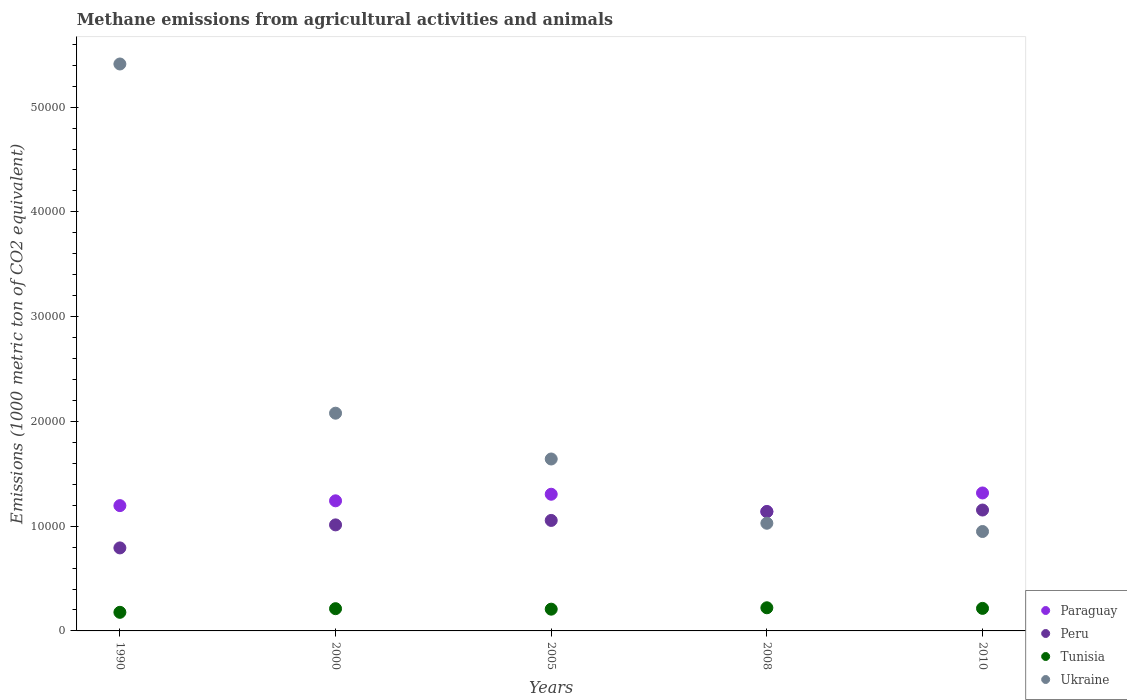What is the amount of methane emitted in Peru in 2010?
Give a very brief answer. 1.15e+04. Across all years, what is the maximum amount of methane emitted in Ukraine?
Offer a very short reply. 5.41e+04. Across all years, what is the minimum amount of methane emitted in Ukraine?
Provide a short and direct response. 9489.8. In which year was the amount of methane emitted in Ukraine minimum?
Ensure brevity in your answer.  2010. What is the total amount of methane emitted in Tunisia in the graph?
Your answer should be very brief. 1.03e+04. What is the difference between the amount of methane emitted in Paraguay in 2005 and that in 2008?
Provide a short and direct response. 1659.4. What is the difference between the amount of methane emitted in Peru in 2005 and the amount of methane emitted in Tunisia in 2010?
Offer a very short reply. 8395.2. What is the average amount of methane emitted in Peru per year?
Offer a very short reply. 1.03e+04. In the year 2005, what is the difference between the amount of methane emitted in Ukraine and amount of methane emitted in Peru?
Offer a very short reply. 5864.3. What is the ratio of the amount of methane emitted in Tunisia in 1990 to that in 2008?
Offer a terse response. 0.8. Is the difference between the amount of methane emitted in Ukraine in 2008 and 2010 greater than the difference between the amount of methane emitted in Peru in 2008 and 2010?
Provide a succinct answer. Yes. What is the difference between the highest and the second highest amount of methane emitted in Tunisia?
Provide a succinct answer. 57.9. What is the difference between the highest and the lowest amount of methane emitted in Paraguay?
Your answer should be compact. 1782.6. In how many years, is the amount of methane emitted in Ukraine greater than the average amount of methane emitted in Ukraine taken over all years?
Make the answer very short. 1. Is the sum of the amount of methane emitted in Tunisia in 2005 and 2008 greater than the maximum amount of methane emitted in Ukraine across all years?
Give a very brief answer. No. Is it the case that in every year, the sum of the amount of methane emitted in Ukraine and amount of methane emitted in Paraguay  is greater than the amount of methane emitted in Peru?
Give a very brief answer. Yes. Does the amount of methane emitted in Peru monotonically increase over the years?
Your answer should be compact. Yes. How many years are there in the graph?
Provide a short and direct response. 5. Does the graph contain any zero values?
Make the answer very short. No. Where does the legend appear in the graph?
Provide a short and direct response. Bottom right. How are the legend labels stacked?
Give a very brief answer. Vertical. What is the title of the graph?
Offer a terse response. Methane emissions from agricultural activities and animals. Does "United States" appear as one of the legend labels in the graph?
Your answer should be very brief. No. What is the label or title of the X-axis?
Provide a short and direct response. Years. What is the label or title of the Y-axis?
Your response must be concise. Emissions (1000 metric ton of CO2 equivalent). What is the Emissions (1000 metric ton of CO2 equivalent) in Paraguay in 1990?
Ensure brevity in your answer.  1.20e+04. What is the Emissions (1000 metric ton of CO2 equivalent) of Peru in 1990?
Provide a succinct answer. 7923.7. What is the Emissions (1000 metric ton of CO2 equivalent) in Tunisia in 1990?
Offer a terse response. 1775.7. What is the Emissions (1000 metric ton of CO2 equivalent) of Ukraine in 1990?
Provide a short and direct response. 5.41e+04. What is the Emissions (1000 metric ton of CO2 equivalent) of Paraguay in 2000?
Make the answer very short. 1.24e+04. What is the Emissions (1000 metric ton of CO2 equivalent) of Peru in 2000?
Your response must be concise. 1.01e+04. What is the Emissions (1000 metric ton of CO2 equivalent) of Tunisia in 2000?
Your answer should be compact. 2123.8. What is the Emissions (1000 metric ton of CO2 equivalent) of Ukraine in 2000?
Keep it short and to the point. 2.08e+04. What is the Emissions (1000 metric ton of CO2 equivalent) in Paraguay in 2005?
Offer a terse response. 1.30e+04. What is the Emissions (1000 metric ton of CO2 equivalent) in Peru in 2005?
Ensure brevity in your answer.  1.05e+04. What is the Emissions (1000 metric ton of CO2 equivalent) in Tunisia in 2005?
Your answer should be very brief. 2076.8. What is the Emissions (1000 metric ton of CO2 equivalent) of Ukraine in 2005?
Provide a short and direct response. 1.64e+04. What is the Emissions (1000 metric ton of CO2 equivalent) of Paraguay in 2008?
Your answer should be very brief. 1.14e+04. What is the Emissions (1000 metric ton of CO2 equivalent) in Peru in 2008?
Your answer should be compact. 1.14e+04. What is the Emissions (1000 metric ton of CO2 equivalent) of Tunisia in 2008?
Provide a short and direct response. 2209.8. What is the Emissions (1000 metric ton of CO2 equivalent) of Ukraine in 2008?
Offer a very short reply. 1.03e+04. What is the Emissions (1000 metric ton of CO2 equivalent) in Paraguay in 2010?
Your answer should be compact. 1.32e+04. What is the Emissions (1000 metric ton of CO2 equivalent) of Peru in 2010?
Your response must be concise. 1.15e+04. What is the Emissions (1000 metric ton of CO2 equivalent) in Tunisia in 2010?
Ensure brevity in your answer.  2151.9. What is the Emissions (1000 metric ton of CO2 equivalent) of Ukraine in 2010?
Provide a short and direct response. 9489.8. Across all years, what is the maximum Emissions (1000 metric ton of CO2 equivalent) in Paraguay?
Keep it short and to the point. 1.32e+04. Across all years, what is the maximum Emissions (1000 metric ton of CO2 equivalent) of Peru?
Offer a terse response. 1.15e+04. Across all years, what is the maximum Emissions (1000 metric ton of CO2 equivalent) in Tunisia?
Provide a short and direct response. 2209.8. Across all years, what is the maximum Emissions (1000 metric ton of CO2 equivalent) of Ukraine?
Keep it short and to the point. 5.41e+04. Across all years, what is the minimum Emissions (1000 metric ton of CO2 equivalent) of Paraguay?
Offer a very short reply. 1.14e+04. Across all years, what is the minimum Emissions (1000 metric ton of CO2 equivalent) in Peru?
Offer a very short reply. 7923.7. Across all years, what is the minimum Emissions (1000 metric ton of CO2 equivalent) in Tunisia?
Keep it short and to the point. 1775.7. Across all years, what is the minimum Emissions (1000 metric ton of CO2 equivalent) in Ukraine?
Give a very brief answer. 9489.8. What is the total Emissions (1000 metric ton of CO2 equivalent) of Paraguay in the graph?
Your answer should be very brief. 6.20e+04. What is the total Emissions (1000 metric ton of CO2 equivalent) in Peru in the graph?
Your response must be concise. 5.15e+04. What is the total Emissions (1000 metric ton of CO2 equivalent) in Tunisia in the graph?
Keep it short and to the point. 1.03e+04. What is the total Emissions (1000 metric ton of CO2 equivalent) in Ukraine in the graph?
Provide a succinct answer. 1.11e+05. What is the difference between the Emissions (1000 metric ton of CO2 equivalent) in Paraguay in 1990 and that in 2000?
Give a very brief answer. -458.8. What is the difference between the Emissions (1000 metric ton of CO2 equivalent) in Peru in 1990 and that in 2000?
Keep it short and to the point. -2198.2. What is the difference between the Emissions (1000 metric ton of CO2 equivalent) of Tunisia in 1990 and that in 2000?
Your answer should be compact. -348.1. What is the difference between the Emissions (1000 metric ton of CO2 equivalent) in Ukraine in 1990 and that in 2000?
Your response must be concise. 3.33e+04. What is the difference between the Emissions (1000 metric ton of CO2 equivalent) in Paraguay in 1990 and that in 2005?
Provide a short and direct response. -1085.6. What is the difference between the Emissions (1000 metric ton of CO2 equivalent) in Peru in 1990 and that in 2005?
Keep it short and to the point. -2623.4. What is the difference between the Emissions (1000 metric ton of CO2 equivalent) of Tunisia in 1990 and that in 2005?
Keep it short and to the point. -301.1. What is the difference between the Emissions (1000 metric ton of CO2 equivalent) in Ukraine in 1990 and that in 2005?
Your answer should be very brief. 3.77e+04. What is the difference between the Emissions (1000 metric ton of CO2 equivalent) of Paraguay in 1990 and that in 2008?
Your answer should be very brief. 573.8. What is the difference between the Emissions (1000 metric ton of CO2 equivalent) of Peru in 1990 and that in 2008?
Provide a short and direct response. -3467.3. What is the difference between the Emissions (1000 metric ton of CO2 equivalent) of Tunisia in 1990 and that in 2008?
Make the answer very short. -434.1. What is the difference between the Emissions (1000 metric ton of CO2 equivalent) in Ukraine in 1990 and that in 2008?
Provide a succinct answer. 4.38e+04. What is the difference between the Emissions (1000 metric ton of CO2 equivalent) of Paraguay in 1990 and that in 2010?
Keep it short and to the point. -1208.8. What is the difference between the Emissions (1000 metric ton of CO2 equivalent) in Peru in 1990 and that in 2010?
Your answer should be very brief. -3615.7. What is the difference between the Emissions (1000 metric ton of CO2 equivalent) of Tunisia in 1990 and that in 2010?
Your answer should be very brief. -376.2. What is the difference between the Emissions (1000 metric ton of CO2 equivalent) of Ukraine in 1990 and that in 2010?
Provide a short and direct response. 4.46e+04. What is the difference between the Emissions (1000 metric ton of CO2 equivalent) in Paraguay in 2000 and that in 2005?
Provide a succinct answer. -626.8. What is the difference between the Emissions (1000 metric ton of CO2 equivalent) in Peru in 2000 and that in 2005?
Keep it short and to the point. -425.2. What is the difference between the Emissions (1000 metric ton of CO2 equivalent) of Tunisia in 2000 and that in 2005?
Offer a terse response. 47. What is the difference between the Emissions (1000 metric ton of CO2 equivalent) in Ukraine in 2000 and that in 2005?
Offer a very short reply. 4372.1. What is the difference between the Emissions (1000 metric ton of CO2 equivalent) of Paraguay in 2000 and that in 2008?
Ensure brevity in your answer.  1032.6. What is the difference between the Emissions (1000 metric ton of CO2 equivalent) in Peru in 2000 and that in 2008?
Offer a very short reply. -1269.1. What is the difference between the Emissions (1000 metric ton of CO2 equivalent) of Tunisia in 2000 and that in 2008?
Keep it short and to the point. -86. What is the difference between the Emissions (1000 metric ton of CO2 equivalent) of Ukraine in 2000 and that in 2008?
Provide a short and direct response. 1.05e+04. What is the difference between the Emissions (1000 metric ton of CO2 equivalent) of Paraguay in 2000 and that in 2010?
Offer a very short reply. -750. What is the difference between the Emissions (1000 metric ton of CO2 equivalent) of Peru in 2000 and that in 2010?
Make the answer very short. -1417.5. What is the difference between the Emissions (1000 metric ton of CO2 equivalent) of Tunisia in 2000 and that in 2010?
Ensure brevity in your answer.  -28.1. What is the difference between the Emissions (1000 metric ton of CO2 equivalent) in Ukraine in 2000 and that in 2010?
Give a very brief answer. 1.13e+04. What is the difference between the Emissions (1000 metric ton of CO2 equivalent) of Paraguay in 2005 and that in 2008?
Give a very brief answer. 1659.4. What is the difference between the Emissions (1000 metric ton of CO2 equivalent) in Peru in 2005 and that in 2008?
Offer a terse response. -843.9. What is the difference between the Emissions (1000 metric ton of CO2 equivalent) in Tunisia in 2005 and that in 2008?
Make the answer very short. -133. What is the difference between the Emissions (1000 metric ton of CO2 equivalent) in Ukraine in 2005 and that in 2008?
Ensure brevity in your answer.  6133.4. What is the difference between the Emissions (1000 metric ton of CO2 equivalent) in Paraguay in 2005 and that in 2010?
Keep it short and to the point. -123.2. What is the difference between the Emissions (1000 metric ton of CO2 equivalent) of Peru in 2005 and that in 2010?
Your answer should be very brief. -992.3. What is the difference between the Emissions (1000 metric ton of CO2 equivalent) of Tunisia in 2005 and that in 2010?
Keep it short and to the point. -75.1. What is the difference between the Emissions (1000 metric ton of CO2 equivalent) in Ukraine in 2005 and that in 2010?
Provide a succinct answer. 6921.6. What is the difference between the Emissions (1000 metric ton of CO2 equivalent) of Paraguay in 2008 and that in 2010?
Provide a short and direct response. -1782.6. What is the difference between the Emissions (1000 metric ton of CO2 equivalent) of Peru in 2008 and that in 2010?
Offer a very short reply. -148.4. What is the difference between the Emissions (1000 metric ton of CO2 equivalent) in Tunisia in 2008 and that in 2010?
Your answer should be very brief. 57.9. What is the difference between the Emissions (1000 metric ton of CO2 equivalent) in Ukraine in 2008 and that in 2010?
Give a very brief answer. 788.2. What is the difference between the Emissions (1000 metric ton of CO2 equivalent) of Paraguay in 1990 and the Emissions (1000 metric ton of CO2 equivalent) of Peru in 2000?
Provide a succinct answer. 1838.5. What is the difference between the Emissions (1000 metric ton of CO2 equivalent) of Paraguay in 1990 and the Emissions (1000 metric ton of CO2 equivalent) of Tunisia in 2000?
Make the answer very short. 9836.6. What is the difference between the Emissions (1000 metric ton of CO2 equivalent) of Paraguay in 1990 and the Emissions (1000 metric ton of CO2 equivalent) of Ukraine in 2000?
Your answer should be very brief. -8823.1. What is the difference between the Emissions (1000 metric ton of CO2 equivalent) in Peru in 1990 and the Emissions (1000 metric ton of CO2 equivalent) in Tunisia in 2000?
Your response must be concise. 5799.9. What is the difference between the Emissions (1000 metric ton of CO2 equivalent) of Peru in 1990 and the Emissions (1000 metric ton of CO2 equivalent) of Ukraine in 2000?
Give a very brief answer. -1.29e+04. What is the difference between the Emissions (1000 metric ton of CO2 equivalent) of Tunisia in 1990 and the Emissions (1000 metric ton of CO2 equivalent) of Ukraine in 2000?
Provide a succinct answer. -1.90e+04. What is the difference between the Emissions (1000 metric ton of CO2 equivalent) in Paraguay in 1990 and the Emissions (1000 metric ton of CO2 equivalent) in Peru in 2005?
Offer a very short reply. 1413.3. What is the difference between the Emissions (1000 metric ton of CO2 equivalent) in Paraguay in 1990 and the Emissions (1000 metric ton of CO2 equivalent) in Tunisia in 2005?
Give a very brief answer. 9883.6. What is the difference between the Emissions (1000 metric ton of CO2 equivalent) of Paraguay in 1990 and the Emissions (1000 metric ton of CO2 equivalent) of Ukraine in 2005?
Offer a terse response. -4451. What is the difference between the Emissions (1000 metric ton of CO2 equivalent) in Peru in 1990 and the Emissions (1000 metric ton of CO2 equivalent) in Tunisia in 2005?
Your answer should be compact. 5846.9. What is the difference between the Emissions (1000 metric ton of CO2 equivalent) in Peru in 1990 and the Emissions (1000 metric ton of CO2 equivalent) in Ukraine in 2005?
Your answer should be very brief. -8487.7. What is the difference between the Emissions (1000 metric ton of CO2 equivalent) of Tunisia in 1990 and the Emissions (1000 metric ton of CO2 equivalent) of Ukraine in 2005?
Offer a very short reply. -1.46e+04. What is the difference between the Emissions (1000 metric ton of CO2 equivalent) of Paraguay in 1990 and the Emissions (1000 metric ton of CO2 equivalent) of Peru in 2008?
Your answer should be very brief. 569.4. What is the difference between the Emissions (1000 metric ton of CO2 equivalent) in Paraguay in 1990 and the Emissions (1000 metric ton of CO2 equivalent) in Tunisia in 2008?
Offer a very short reply. 9750.6. What is the difference between the Emissions (1000 metric ton of CO2 equivalent) in Paraguay in 1990 and the Emissions (1000 metric ton of CO2 equivalent) in Ukraine in 2008?
Give a very brief answer. 1682.4. What is the difference between the Emissions (1000 metric ton of CO2 equivalent) in Peru in 1990 and the Emissions (1000 metric ton of CO2 equivalent) in Tunisia in 2008?
Offer a very short reply. 5713.9. What is the difference between the Emissions (1000 metric ton of CO2 equivalent) of Peru in 1990 and the Emissions (1000 metric ton of CO2 equivalent) of Ukraine in 2008?
Your response must be concise. -2354.3. What is the difference between the Emissions (1000 metric ton of CO2 equivalent) of Tunisia in 1990 and the Emissions (1000 metric ton of CO2 equivalent) of Ukraine in 2008?
Your response must be concise. -8502.3. What is the difference between the Emissions (1000 metric ton of CO2 equivalent) of Paraguay in 1990 and the Emissions (1000 metric ton of CO2 equivalent) of Peru in 2010?
Offer a very short reply. 421. What is the difference between the Emissions (1000 metric ton of CO2 equivalent) in Paraguay in 1990 and the Emissions (1000 metric ton of CO2 equivalent) in Tunisia in 2010?
Provide a short and direct response. 9808.5. What is the difference between the Emissions (1000 metric ton of CO2 equivalent) in Paraguay in 1990 and the Emissions (1000 metric ton of CO2 equivalent) in Ukraine in 2010?
Keep it short and to the point. 2470.6. What is the difference between the Emissions (1000 metric ton of CO2 equivalent) in Peru in 1990 and the Emissions (1000 metric ton of CO2 equivalent) in Tunisia in 2010?
Offer a terse response. 5771.8. What is the difference between the Emissions (1000 metric ton of CO2 equivalent) in Peru in 1990 and the Emissions (1000 metric ton of CO2 equivalent) in Ukraine in 2010?
Offer a terse response. -1566.1. What is the difference between the Emissions (1000 metric ton of CO2 equivalent) in Tunisia in 1990 and the Emissions (1000 metric ton of CO2 equivalent) in Ukraine in 2010?
Give a very brief answer. -7714.1. What is the difference between the Emissions (1000 metric ton of CO2 equivalent) in Paraguay in 2000 and the Emissions (1000 metric ton of CO2 equivalent) in Peru in 2005?
Keep it short and to the point. 1872.1. What is the difference between the Emissions (1000 metric ton of CO2 equivalent) in Paraguay in 2000 and the Emissions (1000 metric ton of CO2 equivalent) in Tunisia in 2005?
Provide a succinct answer. 1.03e+04. What is the difference between the Emissions (1000 metric ton of CO2 equivalent) in Paraguay in 2000 and the Emissions (1000 metric ton of CO2 equivalent) in Ukraine in 2005?
Provide a succinct answer. -3992.2. What is the difference between the Emissions (1000 metric ton of CO2 equivalent) of Peru in 2000 and the Emissions (1000 metric ton of CO2 equivalent) of Tunisia in 2005?
Offer a very short reply. 8045.1. What is the difference between the Emissions (1000 metric ton of CO2 equivalent) of Peru in 2000 and the Emissions (1000 metric ton of CO2 equivalent) of Ukraine in 2005?
Offer a very short reply. -6289.5. What is the difference between the Emissions (1000 metric ton of CO2 equivalent) in Tunisia in 2000 and the Emissions (1000 metric ton of CO2 equivalent) in Ukraine in 2005?
Keep it short and to the point. -1.43e+04. What is the difference between the Emissions (1000 metric ton of CO2 equivalent) of Paraguay in 2000 and the Emissions (1000 metric ton of CO2 equivalent) of Peru in 2008?
Offer a terse response. 1028.2. What is the difference between the Emissions (1000 metric ton of CO2 equivalent) in Paraguay in 2000 and the Emissions (1000 metric ton of CO2 equivalent) in Tunisia in 2008?
Your response must be concise. 1.02e+04. What is the difference between the Emissions (1000 metric ton of CO2 equivalent) in Paraguay in 2000 and the Emissions (1000 metric ton of CO2 equivalent) in Ukraine in 2008?
Provide a short and direct response. 2141.2. What is the difference between the Emissions (1000 metric ton of CO2 equivalent) in Peru in 2000 and the Emissions (1000 metric ton of CO2 equivalent) in Tunisia in 2008?
Keep it short and to the point. 7912.1. What is the difference between the Emissions (1000 metric ton of CO2 equivalent) of Peru in 2000 and the Emissions (1000 metric ton of CO2 equivalent) of Ukraine in 2008?
Your answer should be very brief. -156.1. What is the difference between the Emissions (1000 metric ton of CO2 equivalent) in Tunisia in 2000 and the Emissions (1000 metric ton of CO2 equivalent) in Ukraine in 2008?
Your answer should be compact. -8154.2. What is the difference between the Emissions (1000 metric ton of CO2 equivalent) in Paraguay in 2000 and the Emissions (1000 metric ton of CO2 equivalent) in Peru in 2010?
Give a very brief answer. 879.8. What is the difference between the Emissions (1000 metric ton of CO2 equivalent) of Paraguay in 2000 and the Emissions (1000 metric ton of CO2 equivalent) of Tunisia in 2010?
Your answer should be compact. 1.03e+04. What is the difference between the Emissions (1000 metric ton of CO2 equivalent) of Paraguay in 2000 and the Emissions (1000 metric ton of CO2 equivalent) of Ukraine in 2010?
Provide a short and direct response. 2929.4. What is the difference between the Emissions (1000 metric ton of CO2 equivalent) of Peru in 2000 and the Emissions (1000 metric ton of CO2 equivalent) of Tunisia in 2010?
Keep it short and to the point. 7970. What is the difference between the Emissions (1000 metric ton of CO2 equivalent) of Peru in 2000 and the Emissions (1000 metric ton of CO2 equivalent) of Ukraine in 2010?
Give a very brief answer. 632.1. What is the difference between the Emissions (1000 metric ton of CO2 equivalent) of Tunisia in 2000 and the Emissions (1000 metric ton of CO2 equivalent) of Ukraine in 2010?
Offer a terse response. -7366. What is the difference between the Emissions (1000 metric ton of CO2 equivalent) of Paraguay in 2005 and the Emissions (1000 metric ton of CO2 equivalent) of Peru in 2008?
Offer a terse response. 1655. What is the difference between the Emissions (1000 metric ton of CO2 equivalent) of Paraguay in 2005 and the Emissions (1000 metric ton of CO2 equivalent) of Tunisia in 2008?
Offer a terse response. 1.08e+04. What is the difference between the Emissions (1000 metric ton of CO2 equivalent) of Paraguay in 2005 and the Emissions (1000 metric ton of CO2 equivalent) of Ukraine in 2008?
Offer a very short reply. 2768. What is the difference between the Emissions (1000 metric ton of CO2 equivalent) in Peru in 2005 and the Emissions (1000 metric ton of CO2 equivalent) in Tunisia in 2008?
Provide a succinct answer. 8337.3. What is the difference between the Emissions (1000 metric ton of CO2 equivalent) of Peru in 2005 and the Emissions (1000 metric ton of CO2 equivalent) of Ukraine in 2008?
Offer a terse response. 269.1. What is the difference between the Emissions (1000 metric ton of CO2 equivalent) in Tunisia in 2005 and the Emissions (1000 metric ton of CO2 equivalent) in Ukraine in 2008?
Offer a very short reply. -8201.2. What is the difference between the Emissions (1000 metric ton of CO2 equivalent) in Paraguay in 2005 and the Emissions (1000 metric ton of CO2 equivalent) in Peru in 2010?
Provide a succinct answer. 1506.6. What is the difference between the Emissions (1000 metric ton of CO2 equivalent) of Paraguay in 2005 and the Emissions (1000 metric ton of CO2 equivalent) of Tunisia in 2010?
Make the answer very short. 1.09e+04. What is the difference between the Emissions (1000 metric ton of CO2 equivalent) in Paraguay in 2005 and the Emissions (1000 metric ton of CO2 equivalent) in Ukraine in 2010?
Offer a terse response. 3556.2. What is the difference between the Emissions (1000 metric ton of CO2 equivalent) in Peru in 2005 and the Emissions (1000 metric ton of CO2 equivalent) in Tunisia in 2010?
Ensure brevity in your answer.  8395.2. What is the difference between the Emissions (1000 metric ton of CO2 equivalent) of Peru in 2005 and the Emissions (1000 metric ton of CO2 equivalent) of Ukraine in 2010?
Your answer should be very brief. 1057.3. What is the difference between the Emissions (1000 metric ton of CO2 equivalent) of Tunisia in 2005 and the Emissions (1000 metric ton of CO2 equivalent) of Ukraine in 2010?
Give a very brief answer. -7413. What is the difference between the Emissions (1000 metric ton of CO2 equivalent) of Paraguay in 2008 and the Emissions (1000 metric ton of CO2 equivalent) of Peru in 2010?
Ensure brevity in your answer.  -152.8. What is the difference between the Emissions (1000 metric ton of CO2 equivalent) of Paraguay in 2008 and the Emissions (1000 metric ton of CO2 equivalent) of Tunisia in 2010?
Keep it short and to the point. 9234.7. What is the difference between the Emissions (1000 metric ton of CO2 equivalent) in Paraguay in 2008 and the Emissions (1000 metric ton of CO2 equivalent) in Ukraine in 2010?
Provide a succinct answer. 1896.8. What is the difference between the Emissions (1000 metric ton of CO2 equivalent) in Peru in 2008 and the Emissions (1000 metric ton of CO2 equivalent) in Tunisia in 2010?
Ensure brevity in your answer.  9239.1. What is the difference between the Emissions (1000 metric ton of CO2 equivalent) in Peru in 2008 and the Emissions (1000 metric ton of CO2 equivalent) in Ukraine in 2010?
Ensure brevity in your answer.  1901.2. What is the difference between the Emissions (1000 metric ton of CO2 equivalent) of Tunisia in 2008 and the Emissions (1000 metric ton of CO2 equivalent) of Ukraine in 2010?
Provide a succinct answer. -7280. What is the average Emissions (1000 metric ton of CO2 equivalent) in Paraguay per year?
Ensure brevity in your answer.  1.24e+04. What is the average Emissions (1000 metric ton of CO2 equivalent) of Peru per year?
Your answer should be compact. 1.03e+04. What is the average Emissions (1000 metric ton of CO2 equivalent) of Tunisia per year?
Provide a short and direct response. 2067.6. What is the average Emissions (1000 metric ton of CO2 equivalent) in Ukraine per year?
Make the answer very short. 2.22e+04. In the year 1990, what is the difference between the Emissions (1000 metric ton of CO2 equivalent) of Paraguay and Emissions (1000 metric ton of CO2 equivalent) of Peru?
Your answer should be very brief. 4036.7. In the year 1990, what is the difference between the Emissions (1000 metric ton of CO2 equivalent) of Paraguay and Emissions (1000 metric ton of CO2 equivalent) of Tunisia?
Give a very brief answer. 1.02e+04. In the year 1990, what is the difference between the Emissions (1000 metric ton of CO2 equivalent) in Paraguay and Emissions (1000 metric ton of CO2 equivalent) in Ukraine?
Offer a very short reply. -4.22e+04. In the year 1990, what is the difference between the Emissions (1000 metric ton of CO2 equivalent) of Peru and Emissions (1000 metric ton of CO2 equivalent) of Tunisia?
Give a very brief answer. 6148. In the year 1990, what is the difference between the Emissions (1000 metric ton of CO2 equivalent) in Peru and Emissions (1000 metric ton of CO2 equivalent) in Ukraine?
Make the answer very short. -4.62e+04. In the year 1990, what is the difference between the Emissions (1000 metric ton of CO2 equivalent) in Tunisia and Emissions (1000 metric ton of CO2 equivalent) in Ukraine?
Give a very brief answer. -5.23e+04. In the year 2000, what is the difference between the Emissions (1000 metric ton of CO2 equivalent) of Paraguay and Emissions (1000 metric ton of CO2 equivalent) of Peru?
Keep it short and to the point. 2297.3. In the year 2000, what is the difference between the Emissions (1000 metric ton of CO2 equivalent) in Paraguay and Emissions (1000 metric ton of CO2 equivalent) in Tunisia?
Provide a short and direct response. 1.03e+04. In the year 2000, what is the difference between the Emissions (1000 metric ton of CO2 equivalent) of Paraguay and Emissions (1000 metric ton of CO2 equivalent) of Ukraine?
Keep it short and to the point. -8364.3. In the year 2000, what is the difference between the Emissions (1000 metric ton of CO2 equivalent) of Peru and Emissions (1000 metric ton of CO2 equivalent) of Tunisia?
Ensure brevity in your answer.  7998.1. In the year 2000, what is the difference between the Emissions (1000 metric ton of CO2 equivalent) of Peru and Emissions (1000 metric ton of CO2 equivalent) of Ukraine?
Provide a short and direct response. -1.07e+04. In the year 2000, what is the difference between the Emissions (1000 metric ton of CO2 equivalent) of Tunisia and Emissions (1000 metric ton of CO2 equivalent) of Ukraine?
Your answer should be compact. -1.87e+04. In the year 2005, what is the difference between the Emissions (1000 metric ton of CO2 equivalent) in Paraguay and Emissions (1000 metric ton of CO2 equivalent) in Peru?
Give a very brief answer. 2498.9. In the year 2005, what is the difference between the Emissions (1000 metric ton of CO2 equivalent) of Paraguay and Emissions (1000 metric ton of CO2 equivalent) of Tunisia?
Offer a very short reply. 1.10e+04. In the year 2005, what is the difference between the Emissions (1000 metric ton of CO2 equivalent) of Paraguay and Emissions (1000 metric ton of CO2 equivalent) of Ukraine?
Give a very brief answer. -3365.4. In the year 2005, what is the difference between the Emissions (1000 metric ton of CO2 equivalent) in Peru and Emissions (1000 metric ton of CO2 equivalent) in Tunisia?
Keep it short and to the point. 8470.3. In the year 2005, what is the difference between the Emissions (1000 metric ton of CO2 equivalent) in Peru and Emissions (1000 metric ton of CO2 equivalent) in Ukraine?
Your response must be concise. -5864.3. In the year 2005, what is the difference between the Emissions (1000 metric ton of CO2 equivalent) of Tunisia and Emissions (1000 metric ton of CO2 equivalent) of Ukraine?
Your response must be concise. -1.43e+04. In the year 2008, what is the difference between the Emissions (1000 metric ton of CO2 equivalent) of Paraguay and Emissions (1000 metric ton of CO2 equivalent) of Peru?
Make the answer very short. -4.4. In the year 2008, what is the difference between the Emissions (1000 metric ton of CO2 equivalent) in Paraguay and Emissions (1000 metric ton of CO2 equivalent) in Tunisia?
Your answer should be very brief. 9176.8. In the year 2008, what is the difference between the Emissions (1000 metric ton of CO2 equivalent) of Paraguay and Emissions (1000 metric ton of CO2 equivalent) of Ukraine?
Offer a very short reply. 1108.6. In the year 2008, what is the difference between the Emissions (1000 metric ton of CO2 equivalent) of Peru and Emissions (1000 metric ton of CO2 equivalent) of Tunisia?
Provide a succinct answer. 9181.2. In the year 2008, what is the difference between the Emissions (1000 metric ton of CO2 equivalent) in Peru and Emissions (1000 metric ton of CO2 equivalent) in Ukraine?
Your answer should be compact. 1113. In the year 2008, what is the difference between the Emissions (1000 metric ton of CO2 equivalent) in Tunisia and Emissions (1000 metric ton of CO2 equivalent) in Ukraine?
Offer a terse response. -8068.2. In the year 2010, what is the difference between the Emissions (1000 metric ton of CO2 equivalent) of Paraguay and Emissions (1000 metric ton of CO2 equivalent) of Peru?
Provide a short and direct response. 1629.8. In the year 2010, what is the difference between the Emissions (1000 metric ton of CO2 equivalent) of Paraguay and Emissions (1000 metric ton of CO2 equivalent) of Tunisia?
Provide a succinct answer. 1.10e+04. In the year 2010, what is the difference between the Emissions (1000 metric ton of CO2 equivalent) of Paraguay and Emissions (1000 metric ton of CO2 equivalent) of Ukraine?
Make the answer very short. 3679.4. In the year 2010, what is the difference between the Emissions (1000 metric ton of CO2 equivalent) in Peru and Emissions (1000 metric ton of CO2 equivalent) in Tunisia?
Offer a very short reply. 9387.5. In the year 2010, what is the difference between the Emissions (1000 metric ton of CO2 equivalent) of Peru and Emissions (1000 metric ton of CO2 equivalent) of Ukraine?
Give a very brief answer. 2049.6. In the year 2010, what is the difference between the Emissions (1000 metric ton of CO2 equivalent) in Tunisia and Emissions (1000 metric ton of CO2 equivalent) in Ukraine?
Provide a short and direct response. -7337.9. What is the ratio of the Emissions (1000 metric ton of CO2 equivalent) of Paraguay in 1990 to that in 2000?
Offer a terse response. 0.96. What is the ratio of the Emissions (1000 metric ton of CO2 equivalent) in Peru in 1990 to that in 2000?
Offer a terse response. 0.78. What is the ratio of the Emissions (1000 metric ton of CO2 equivalent) in Tunisia in 1990 to that in 2000?
Provide a succinct answer. 0.84. What is the ratio of the Emissions (1000 metric ton of CO2 equivalent) of Ukraine in 1990 to that in 2000?
Give a very brief answer. 2.6. What is the ratio of the Emissions (1000 metric ton of CO2 equivalent) of Paraguay in 1990 to that in 2005?
Make the answer very short. 0.92. What is the ratio of the Emissions (1000 metric ton of CO2 equivalent) in Peru in 1990 to that in 2005?
Ensure brevity in your answer.  0.75. What is the ratio of the Emissions (1000 metric ton of CO2 equivalent) of Tunisia in 1990 to that in 2005?
Keep it short and to the point. 0.85. What is the ratio of the Emissions (1000 metric ton of CO2 equivalent) of Ukraine in 1990 to that in 2005?
Provide a succinct answer. 3.3. What is the ratio of the Emissions (1000 metric ton of CO2 equivalent) in Paraguay in 1990 to that in 2008?
Offer a terse response. 1.05. What is the ratio of the Emissions (1000 metric ton of CO2 equivalent) of Peru in 1990 to that in 2008?
Keep it short and to the point. 0.7. What is the ratio of the Emissions (1000 metric ton of CO2 equivalent) of Tunisia in 1990 to that in 2008?
Your answer should be very brief. 0.8. What is the ratio of the Emissions (1000 metric ton of CO2 equivalent) in Ukraine in 1990 to that in 2008?
Give a very brief answer. 5.27. What is the ratio of the Emissions (1000 metric ton of CO2 equivalent) in Paraguay in 1990 to that in 2010?
Offer a very short reply. 0.91. What is the ratio of the Emissions (1000 metric ton of CO2 equivalent) of Peru in 1990 to that in 2010?
Keep it short and to the point. 0.69. What is the ratio of the Emissions (1000 metric ton of CO2 equivalent) of Tunisia in 1990 to that in 2010?
Provide a succinct answer. 0.83. What is the ratio of the Emissions (1000 metric ton of CO2 equivalent) in Ukraine in 1990 to that in 2010?
Keep it short and to the point. 5.7. What is the ratio of the Emissions (1000 metric ton of CO2 equivalent) in Paraguay in 2000 to that in 2005?
Provide a short and direct response. 0.95. What is the ratio of the Emissions (1000 metric ton of CO2 equivalent) of Peru in 2000 to that in 2005?
Make the answer very short. 0.96. What is the ratio of the Emissions (1000 metric ton of CO2 equivalent) in Tunisia in 2000 to that in 2005?
Your answer should be very brief. 1.02. What is the ratio of the Emissions (1000 metric ton of CO2 equivalent) in Ukraine in 2000 to that in 2005?
Make the answer very short. 1.27. What is the ratio of the Emissions (1000 metric ton of CO2 equivalent) of Paraguay in 2000 to that in 2008?
Make the answer very short. 1.09. What is the ratio of the Emissions (1000 metric ton of CO2 equivalent) of Peru in 2000 to that in 2008?
Ensure brevity in your answer.  0.89. What is the ratio of the Emissions (1000 metric ton of CO2 equivalent) in Tunisia in 2000 to that in 2008?
Provide a succinct answer. 0.96. What is the ratio of the Emissions (1000 metric ton of CO2 equivalent) of Ukraine in 2000 to that in 2008?
Provide a short and direct response. 2.02. What is the ratio of the Emissions (1000 metric ton of CO2 equivalent) of Paraguay in 2000 to that in 2010?
Give a very brief answer. 0.94. What is the ratio of the Emissions (1000 metric ton of CO2 equivalent) in Peru in 2000 to that in 2010?
Your response must be concise. 0.88. What is the ratio of the Emissions (1000 metric ton of CO2 equivalent) of Tunisia in 2000 to that in 2010?
Ensure brevity in your answer.  0.99. What is the ratio of the Emissions (1000 metric ton of CO2 equivalent) in Ukraine in 2000 to that in 2010?
Your answer should be very brief. 2.19. What is the ratio of the Emissions (1000 metric ton of CO2 equivalent) in Paraguay in 2005 to that in 2008?
Make the answer very short. 1.15. What is the ratio of the Emissions (1000 metric ton of CO2 equivalent) of Peru in 2005 to that in 2008?
Offer a very short reply. 0.93. What is the ratio of the Emissions (1000 metric ton of CO2 equivalent) of Tunisia in 2005 to that in 2008?
Give a very brief answer. 0.94. What is the ratio of the Emissions (1000 metric ton of CO2 equivalent) in Ukraine in 2005 to that in 2008?
Your response must be concise. 1.6. What is the ratio of the Emissions (1000 metric ton of CO2 equivalent) in Paraguay in 2005 to that in 2010?
Keep it short and to the point. 0.99. What is the ratio of the Emissions (1000 metric ton of CO2 equivalent) of Peru in 2005 to that in 2010?
Offer a terse response. 0.91. What is the ratio of the Emissions (1000 metric ton of CO2 equivalent) of Tunisia in 2005 to that in 2010?
Give a very brief answer. 0.97. What is the ratio of the Emissions (1000 metric ton of CO2 equivalent) of Ukraine in 2005 to that in 2010?
Your answer should be compact. 1.73. What is the ratio of the Emissions (1000 metric ton of CO2 equivalent) in Paraguay in 2008 to that in 2010?
Make the answer very short. 0.86. What is the ratio of the Emissions (1000 metric ton of CO2 equivalent) in Peru in 2008 to that in 2010?
Provide a succinct answer. 0.99. What is the ratio of the Emissions (1000 metric ton of CO2 equivalent) in Tunisia in 2008 to that in 2010?
Provide a short and direct response. 1.03. What is the ratio of the Emissions (1000 metric ton of CO2 equivalent) in Ukraine in 2008 to that in 2010?
Ensure brevity in your answer.  1.08. What is the difference between the highest and the second highest Emissions (1000 metric ton of CO2 equivalent) of Paraguay?
Give a very brief answer. 123.2. What is the difference between the highest and the second highest Emissions (1000 metric ton of CO2 equivalent) in Peru?
Offer a very short reply. 148.4. What is the difference between the highest and the second highest Emissions (1000 metric ton of CO2 equivalent) of Tunisia?
Offer a terse response. 57.9. What is the difference between the highest and the second highest Emissions (1000 metric ton of CO2 equivalent) of Ukraine?
Give a very brief answer. 3.33e+04. What is the difference between the highest and the lowest Emissions (1000 metric ton of CO2 equivalent) of Paraguay?
Provide a short and direct response. 1782.6. What is the difference between the highest and the lowest Emissions (1000 metric ton of CO2 equivalent) in Peru?
Offer a very short reply. 3615.7. What is the difference between the highest and the lowest Emissions (1000 metric ton of CO2 equivalent) of Tunisia?
Keep it short and to the point. 434.1. What is the difference between the highest and the lowest Emissions (1000 metric ton of CO2 equivalent) of Ukraine?
Offer a very short reply. 4.46e+04. 